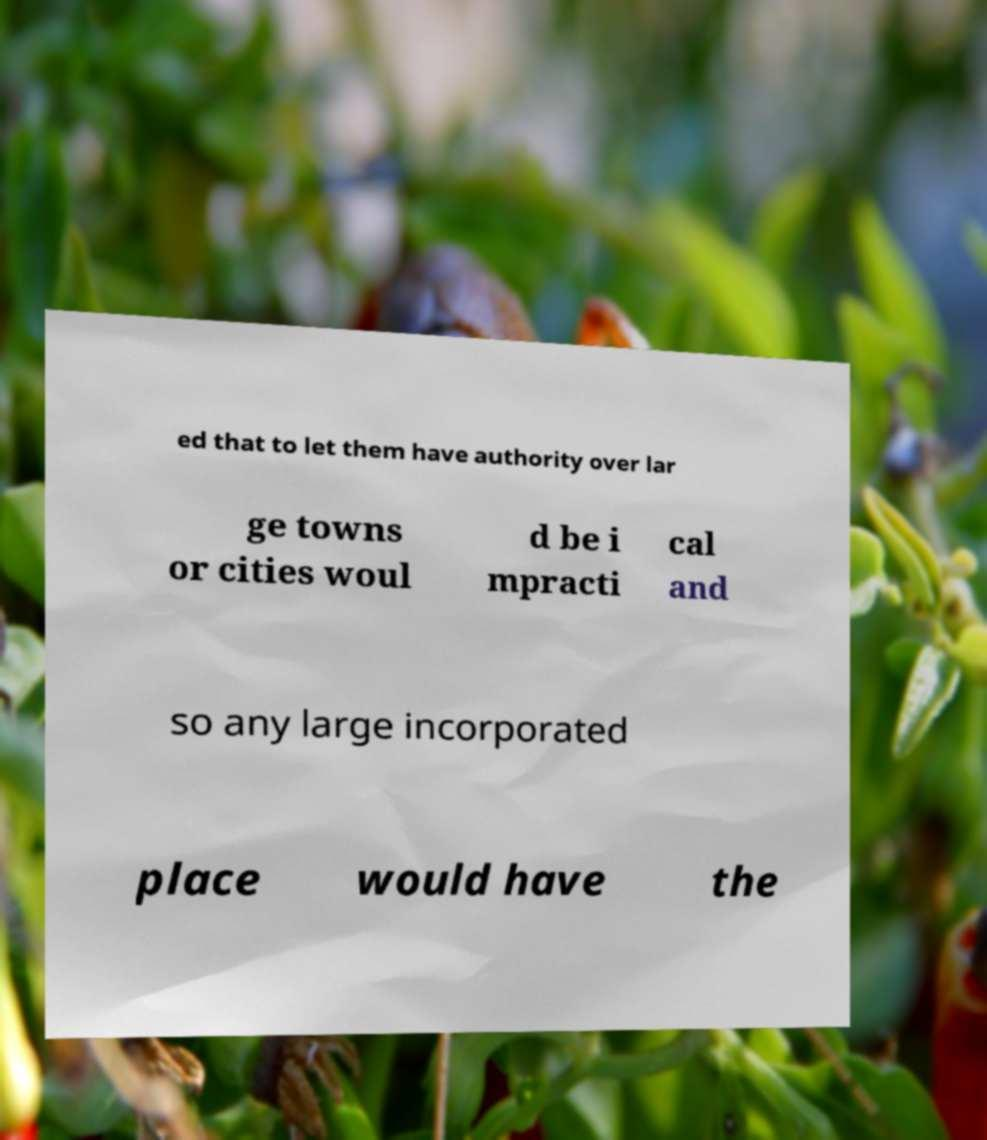What messages or text are displayed in this image? I need them in a readable, typed format. ed that to let them have authority over lar ge towns or cities woul d be i mpracti cal and so any large incorporated place would have the 